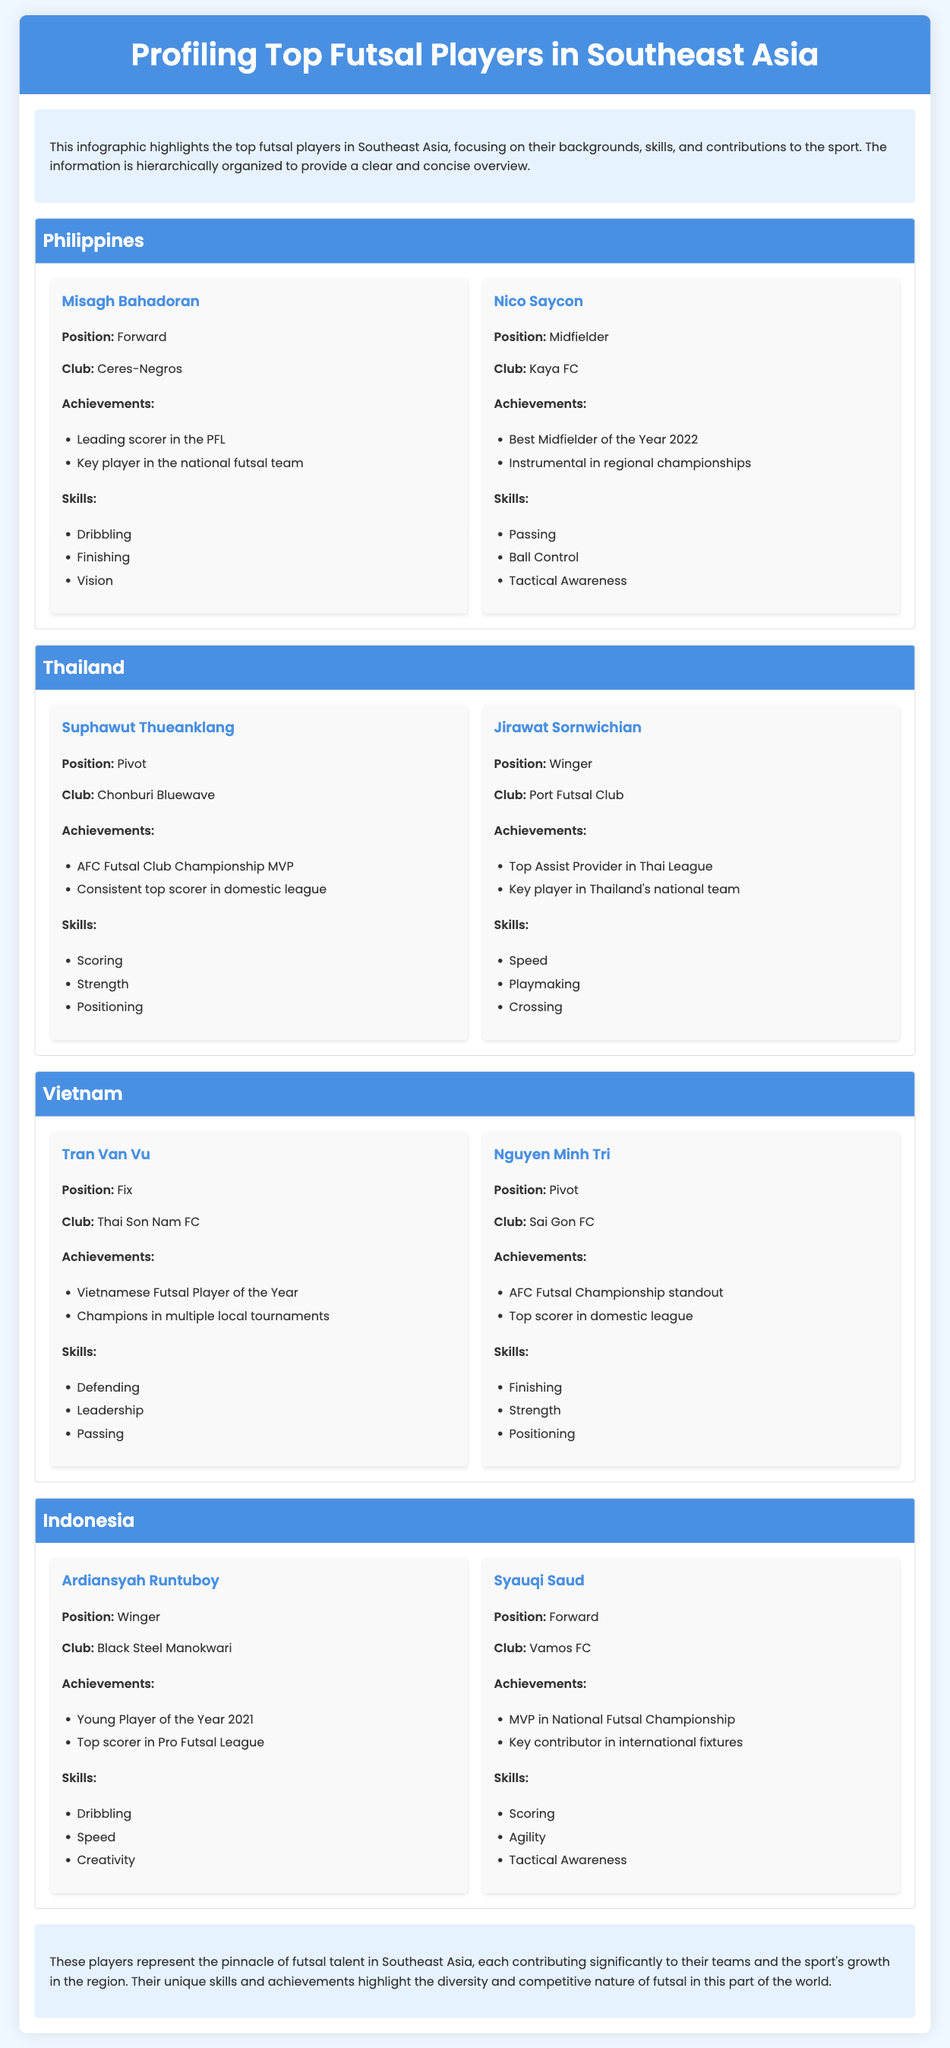What is the title of the document? The title is prominently displayed at the top of the infographic.
Answer: Profiling Top Futsal Players in Southeast Asia Who is the forward player from the Philippines? The document provides names and positions of players, and Misagh Bahadoran is listed as a forward for the Philippines.
Answer: Misagh Bahadoran How many achievements does Suphawut Thueanklang have listed? The achievements are listed in a bullet format under each player, and Suphawut has two achievements mentioned.
Answer: 2 Which player has the best midfielder award in 2022? The document includes specific achievements for players, and Nico Saycon is noted for this award.
Answer: Nico Saycon What position does Tran Van Vu play? The positions of players are stated in the document, and Tran Van Vu is listed as a Fix.
Answer: Fix Which country does Jirawat Sornwichian represent? The country associated with each player is specified, with Jirawat being from Thailand.
Answer: Thailand What skill is associated with Ardiansyah Runtuboy? Skills are listed for each player, and one of Ardiansyah's skills is dribbling.
Answer: Dribbling How many players are profiled from Indonesia? The document includes specific sections for each country, and there are two players profiled from Indonesia.
Answer: 2 What is the club of Nguyen Minh Tri? The club affiliations are provided for each player; Nguyen Minh Tri is listed as playing for Sai Gon FC.
Answer: Sai Gon FC 